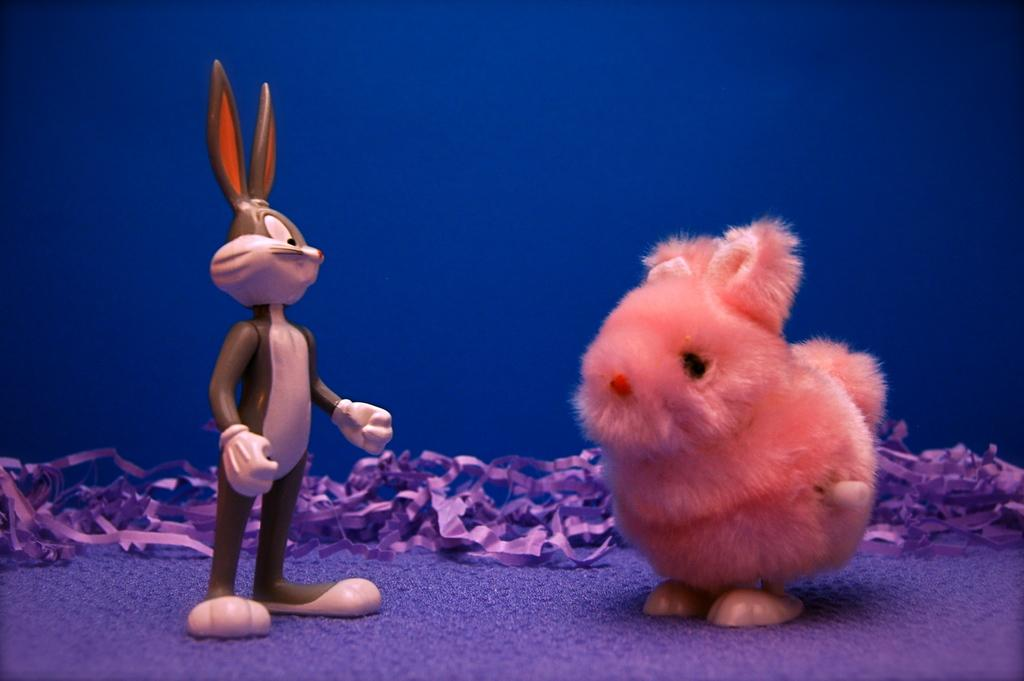What type of character can be seen in the image? There is a character resembling Bugs Bunny in the image. What animal does the character resemble? The character resembles a rabbit. Where are the characters located in the image? Both characters are on the floor. What additional objects can be seen in the image? There are ribbons visible in the image. What language is the rabbit speaking in the image? The image does not provide any information about the language spoken by the rabbit or any other character. Can you see any insects in the image? There are no insects visible in the image. 